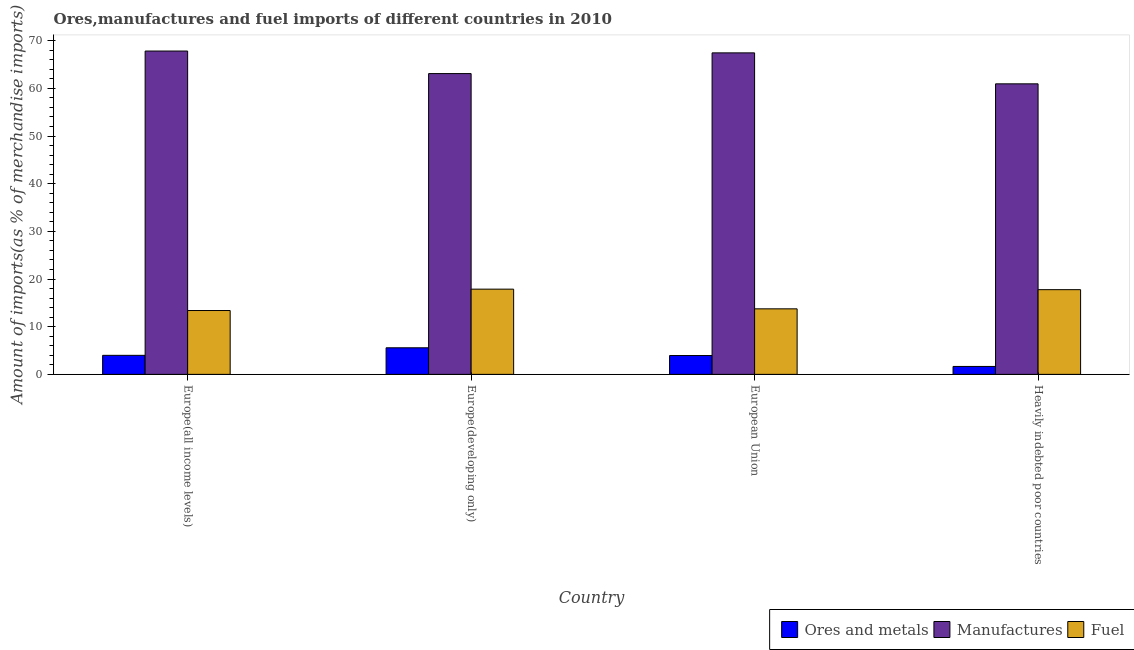How many groups of bars are there?
Your response must be concise. 4. Are the number of bars per tick equal to the number of legend labels?
Ensure brevity in your answer.  Yes. Are the number of bars on each tick of the X-axis equal?
Ensure brevity in your answer.  Yes. What is the label of the 3rd group of bars from the left?
Ensure brevity in your answer.  European Union. What is the percentage of ores and metals imports in Heavily indebted poor countries?
Provide a succinct answer. 1.66. Across all countries, what is the maximum percentage of fuel imports?
Your answer should be very brief. 17.88. Across all countries, what is the minimum percentage of manufactures imports?
Your answer should be very brief. 60.94. In which country was the percentage of manufactures imports maximum?
Give a very brief answer. Europe(all income levels). In which country was the percentage of fuel imports minimum?
Your answer should be very brief. Europe(all income levels). What is the total percentage of manufactures imports in the graph?
Provide a succinct answer. 259.3. What is the difference between the percentage of ores and metals imports in Europe(all income levels) and that in Heavily indebted poor countries?
Offer a very short reply. 2.33. What is the difference between the percentage of manufactures imports in Europe(all income levels) and the percentage of fuel imports in Europe(developing only)?
Provide a succinct answer. 49.95. What is the average percentage of fuel imports per country?
Offer a terse response. 15.7. What is the difference between the percentage of fuel imports and percentage of manufactures imports in Heavily indebted poor countries?
Give a very brief answer. -43.17. What is the ratio of the percentage of ores and metals imports in Europe(developing only) to that in Heavily indebted poor countries?
Your response must be concise. 3.36. Is the percentage of fuel imports in Europe(developing only) less than that in European Union?
Provide a short and direct response. No. What is the difference between the highest and the second highest percentage of ores and metals imports?
Your answer should be compact. 1.58. What is the difference between the highest and the lowest percentage of ores and metals imports?
Your answer should be compact. 3.91. What does the 2nd bar from the left in Europe(developing only) represents?
Make the answer very short. Manufactures. What does the 3rd bar from the right in Heavily indebted poor countries represents?
Offer a terse response. Ores and metals. How many bars are there?
Make the answer very short. 12. What is the difference between two consecutive major ticks on the Y-axis?
Provide a succinct answer. 10. How many legend labels are there?
Your response must be concise. 3. What is the title of the graph?
Your answer should be very brief. Ores,manufactures and fuel imports of different countries in 2010. What is the label or title of the X-axis?
Your answer should be compact. Country. What is the label or title of the Y-axis?
Your answer should be very brief. Amount of imports(as % of merchandise imports). What is the Amount of imports(as % of merchandise imports) in Ores and metals in Europe(all income levels)?
Provide a succinct answer. 3.99. What is the Amount of imports(as % of merchandise imports) of Manufactures in Europe(all income levels)?
Provide a succinct answer. 67.82. What is the Amount of imports(as % of merchandise imports) of Fuel in Europe(all income levels)?
Your answer should be very brief. 13.39. What is the Amount of imports(as % of merchandise imports) of Ores and metals in Europe(developing only)?
Offer a terse response. 5.58. What is the Amount of imports(as % of merchandise imports) of Manufactures in Europe(developing only)?
Your answer should be compact. 63.09. What is the Amount of imports(as % of merchandise imports) of Fuel in Europe(developing only)?
Offer a terse response. 17.88. What is the Amount of imports(as % of merchandise imports) in Ores and metals in European Union?
Provide a short and direct response. 3.95. What is the Amount of imports(as % of merchandise imports) in Manufactures in European Union?
Make the answer very short. 67.44. What is the Amount of imports(as % of merchandise imports) of Fuel in European Union?
Your answer should be compact. 13.75. What is the Amount of imports(as % of merchandise imports) in Ores and metals in Heavily indebted poor countries?
Keep it short and to the point. 1.66. What is the Amount of imports(as % of merchandise imports) in Manufactures in Heavily indebted poor countries?
Your answer should be compact. 60.94. What is the Amount of imports(as % of merchandise imports) of Fuel in Heavily indebted poor countries?
Keep it short and to the point. 17.77. Across all countries, what is the maximum Amount of imports(as % of merchandise imports) of Ores and metals?
Provide a short and direct response. 5.58. Across all countries, what is the maximum Amount of imports(as % of merchandise imports) of Manufactures?
Keep it short and to the point. 67.82. Across all countries, what is the maximum Amount of imports(as % of merchandise imports) in Fuel?
Offer a terse response. 17.88. Across all countries, what is the minimum Amount of imports(as % of merchandise imports) in Ores and metals?
Offer a terse response. 1.66. Across all countries, what is the minimum Amount of imports(as % of merchandise imports) in Manufactures?
Your response must be concise. 60.94. Across all countries, what is the minimum Amount of imports(as % of merchandise imports) of Fuel?
Your response must be concise. 13.39. What is the total Amount of imports(as % of merchandise imports) in Ores and metals in the graph?
Ensure brevity in your answer.  15.18. What is the total Amount of imports(as % of merchandise imports) of Manufactures in the graph?
Keep it short and to the point. 259.3. What is the total Amount of imports(as % of merchandise imports) in Fuel in the graph?
Ensure brevity in your answer.  62.78. What is the difference between the Amount of imports(as % of merchandise imports) in Ores and metals in Europe(all income levels) and that in Europe(developing only)?
Keep it short and to the point. -1.58. What is the difference between the Amount of imports(as % of merchandise imports) of Manufactures in Europe(all income levels) and that in Europe(developing only)?
Your answer should be compact. 4.73. What is the difference between the Amount of imports(as % of merchandise imports) of Fuel in Europe(all income levels) and that in Europe(developing only)?
Your response must be concise. -4.48. What is the difference between the Amount of imports(as % of merchandise imports) in Ores and metals in Europe(all income levels) and that in European Union?
Provide a short and direct response. 0.04. What is the difference between the Amount of imports(as % of merchandise imports) in Manufactures in Europe(all income levels) and that in European Union?
Make the answer very short. 0.38. What is the difference between the Amount of imports(as % of merchandise imports) of Fuel in Europe(all income levels) and that in European Union?
Your answer should be compact. -0.36. What is the difference between the Amount of imports(as % of merchandise imports) in Ores and metals in Europe(all income levels) and that in Heavily indebted poor countries?
Make the answer very short. 2.33. What is the difference between the Amount of imports(as % of merchandise imports) of Manufactures in Europe(all income levels) and that in Heavily indebted poor countries?
Make the answer very short. 6.88. What is the difference between the Amount of imports(as % of merchandise imports) in Fuel in Europe(all income levels) and that in Heavily indebted poor countries?
Provide a succinct answer. -4.38. What is the difference between the Amount of imports(as % of merchandise imports) in Ores and metals in Europe(developing only) and that in European Union?
Provide a short and direct response. 1.62. What is the difference between the Amount of imports(as % of merchandise imports) of Manufactures in Europe(developing only) and that in European Union?
Give a very brief answer. -4.34. What is the difference between the Amount of imports(as % of merchandise imports) in Fuel in Europe(developing only) and that in European Union?
Offer a terse response. 4.13. What is the difference between the Amount of imports(as % of merchandise imports) in Ores and metals in Europe(developing only) and that in Heavily indebted poor countries?
Give a very brief answer. 3.91. What is the difference between the Amount of imports(as % of merchandise imports) of Manufactures in Europe(developing only) and that in Heavily indebted poor countries?
Give a very brief answer. 2.15. What is the difference between the Amount of imports(as % of merchandise imports) in Fuel in Europe(developing only) and that in Heavily indebted poor countries?
Your answer should be compact. 0.11. What is the difference between the Amount of imports(as % of merchandise imports) of Ores and metals in European Union and that in Heavily indebted poor countries?
Make the answer very short. 2.29. What is the difference between the Amount of imports(as % of merchandise imports) in Manufactures in European Union and that in Heavily indebted poor countries?
Your response must be concise. 6.5. What is the difference between the Amount of imports(as % of merchandise imports) of Fuel in European Union and that in Heavily indebted poor countries?
Your response must be concise. -4.02. What is the difference between the Amount of imports(as % of merchandise imports) in Ores and metals in Europe(all income levels) and the Amount of imports(as % of merchandise imports) in Manufactures in Europe(developing only)?
Make the answer very short. -59.1. What is the difference between the Amount of imports(as % of merchandise imports) of Ores and metals in Europe(all income levels) and the Amount of imports(as % of merchandise imports) of Fuel in Europe(developing only)?
Offer a terse response. -13.88. What is the difference between the Amount of imports(as % of merchandise imports) in Manufactures in Europe(all income levels) and the Amount of imports(as % of merchandise imports) in Fuel in Europe(developing only)?
Your response must be concise. 49.95. What is the difference between the Amount of imports(as % of merchandise imports) in Ores and metals in Europe(all income levels) and the Amount of imports(as % of merchandise imports) in Manufactures in European Union?
Give a very brief answer. -63.44. What is the difference between the Amount of imports(as % of merchandise imports) in Ores and metals in Europe(all income levels) and the Amount of imports(as % of merchandise imports) in Fuel in European Union?
Give a very brief answer. -9.75. What is the difference between the Amount of imports(as % of merchandise imports) of Manufactures in Europe(all income levels) and the Amount of imports(as % of merchandise imports) of Fuel in European Union?
Provide a short and direct response. 54.07. What is the difference between the Amount of imports(as % of merchandise imports) in Ores and metals in Europe(all income levels) and the Amount of imports(as % of merchandise imports) in Manufactures in Heavily indebted poor countries?
Give a very brief answer. -56.95. What is the difference between the Amount of imports(as % of merchandise imports) of Ores and metals in Europe(all income levels) and the Amount of imports(as % of merchandise imports) of Fuel in Heavily indebted poor countries?
Offer a very short reply. -13.77. What is the difference between the Amount of imports(as % of merchandise imports) of Manufactures in Europe(all income levels) and the Amount of imports(as % of merchandise imports) of Fuel in Heavily indebted poor countries?
Provide a short and direct response. 50.05. What is the difference between the Amount of imports(as % of merchandise imports) in Ores and metals in Europe(developing only) and the Amount of imports(as % of merchandise imports) in Manufactures in European Union?
Provide a short and direct response. -61.86. What is the difference between the Amount of imports(as % of merchandise imports) of Ores and metals in Europe(developing only) and the Amount of imports(as % of merchandise imports) of Fuel in European Union?
Offer a very short reply. -8.17. What is the difference between the Amount of imports(as % of merchandise imports) in Manufactures in Europe(developing only) and the Amount of imports(as % of merchandise imports) in Fuel in European Union?
Provide a short and direct response. 49.35. What is the difference between the Amount of imports(as % of merchandise imports) of Ores and metals in Europe(developing only) and the Amount of imports(as % of merchandise imports) of Manufactures in Heavily indebted poor countries?
Provide a short and direct response. -55.37. What is the difference between the Amount of imports(as % of merchandise imports) in Ores and metals in Europe(developing only) and the Amount of imports(as % of merchandise imports) in Fuel in Heavily indebted poor countries?
Provide a succinct answer. -12.19. What is the difference between the Amount of imports(as % of merchandise imports) of Manufactures in Europe(developing only) and the Amount of imports(as % of merchandise imports) of Fuel in Heavily indebted poor countries?
Make the answer very short. 45.33. What is the difference between the Amount of imports(as % of merchandise imports) in Ores and metals in European Union and the Amount of imports(as % of merchandise imports) in Manufactures in Heavily indebted poor countries?
Provide a succinct answer. -56.99. What is the difference between the Amount of imports(as % of merchandise imports) in Ores and metals in European Union and the Amount of imports(as % of merchandise imports) in Fuel in Heavily indebted poor countries?
Provide a succinct answer. -13.82. What is the difference between the Amount of imports(as % of merchandise imports) of Manufactures in European Union and the Amount of imports(as % of merchandise imports) of Fuel in Heavily indebted poor countries?
Your answer should be very brief. 49.67. What is the average Amount of imports(as % of merchandise imports) of Ores and metals per country?
Make the answer very short. 3.8. What is the average Amount of imports(as % of merchandise imports) in Manufactures per country?
Provide a short and direct response. 64.82. What is the average Amount of imports(as % of merchandise imports) in Fuel per country?
Your response must be concise. 15.7. What is the difference between the Amount of imports(as % of merchandise imports) of Ores and metals and Amount of imports(as % of merchandise imports) of Manufactures in Europe(all income levels)?
Your answer should be very brief. -63.83. What is the difference between the Amount of imports(as % of merchandise imports) of Ores and metals and Amount of imports(as % of merchandise imports) of Fuel in Europe(all income levels)?
Your response must be concise. -9.4. What is the difference between the Amount of imports(as % of merchandise imports) of Manufactures and Amount of imports(as % of merchandise imports) of Fuel in Europe(all income levels)?
Ensure brevity in your answer.  54.43. What is the difference between the Amount of imports(as % of merchandise imports) of Ores and metals and Amount of imports(as % of merchandise imports) of Manufactures in Europe(developing only)?
Your answer should be very brief. -57.52. What is the difference between the Amount of imports(as % of merchandise imports) of Ores and metals and Amount of imports(as % of merchandise imports) of Fuel in Europe(developing only)?
Ensure brevity in your answer.  -12.3. What is the difference between the Amount of imports(as % of merchandise imports) in Manufactures and Amount of imports(as % of merchandise imports) in Fuel in Europe(developing only)?
Offer a terse response. 45.22. What is the difference between the Amount of imports(as % of merchandise imports) in Ores and metals and Amount of imports(as % of merchandise imports) in Manufactures in European Union?
Your response must be concise. -63.49. What is the difference between the Amount of imports(as % of merchandise imports) in Ores and metals and Amount of imports(as % of merchandise imports) in Fuel in European Union?
Provide a succinct answer. -9.8. What is the difference between the Amount of imports(as % of merchandise imports) of Manufactures and Amount of imports(as % of merchandise imports) of Fuel in European Union?
Your answer should be very brief. 53.69. What is the difference between the Amount of imports(as % of merchandise imports) of Ores and metals and Amount of imports(as % of merchandise imports) of Manufactures in Heavily indebted poor countries?
Keep it short and to the point. -59.28. What is the difference between the Amount of imports(as % of merchandise imports) of Ores and metals and Amount of imports(as % of merchandise imports) of Fuel in Heavily indebted poor countries?
Ensure brevity in your answer.  -16.11. What is the difference between the Amount of imports(as % of merchandise imports) of Manufactures and Amount of imports(as % of merchandise imports) of Fuel in Heavily indebted poor countries?
Your answer should be very brief. 43.17. What is the ratio of the Amount of imports(as % of merchandise imports) in Ores and metals in Europe(all income levels) to that in Europe(developing only)?
Offer a very short reply. 0.72. What is the ratio of the Amount of imports(as % of merchandise imports) in Manufactures in Europe(all income levels) to that in Europe(developing only)?
Your answer should be very brief. 1.07. What is the ratio of the Amount of imports(as % of merchandise imports) in Fuel in Europe(all income levels) to that in Europe(developing only)?
Provide a short and direct response. 0.75. What is the ratio of the Amount of imports(as % of merchandise imports) of Ores and metals in Europe(all income levels) to that in European Union?
Make the answer very short. 1.01. What is the ratio of the Amount of imports(as % of merchandise imports) in Manufactures in Europe(all income levels) to that in European Union?
Ensure brevity in your answer.  1.01. What is the ratio of the Amount of imports(as % of merchandise imports) in Fuel in Europe(all income levels) to that in European Union?
Provide a short and direct response. 0.97. What is the ratio of the Amount of imports(as % of merchandise imports) in Ores and metals in Europe(all income levels) to that in Heavily indebted poor countries?
Keep it short and to the point. 2.4. What is the ratio of the Amount of imports(as % of merchandise imports) of Manufactures in Europe(all income levels) to that in Heavily indebted poor countries?
Your answer should be compact. 1.11. What is the ratio of the Amount of imports(as % of merchandise imports) of Fuel in Europe(all income levels) to that in Heavily indebted poor countries?
Your answer should be compact. 0.75. What is the ratio of the Amount of imports(as % of merchandise imports) of Ores and metals in Europe(developing only) to that in European Union?
Offer a terse response. 1.41. What is the ratio of the Amount of imports(as % of merchandise imports) of Manufactures in Europe(developing only) to that in European Union?
Give a very brief answer. 0.94. What is the ratio of the Amount of imports(as % of merchandise imports) of Fuel in Europe(developing only) to that in European Union?
Your answer should be compact. 1.3. What is the ratio of the Amount of imports(as % of merchandise imports) in Ores and metals in Europe(developing only) to that in Heavily indebted poor countries?
Offer a terse response. 3.36. What is the ratio of the Amount of imports(as % of merchandise imports) in Manufactures in Europe(developing only) to that in Heavily indebted poor countries?
Give a very brief answer. 1.04. What is the ratio of the Amount of imports(as % of merchandise imports) in Ores and metals in European Union to that in Heavily indebted poor countries?
Provide a succinct answer. 2.38. What is the ratio of the Amount of imports(as % of merchandise imports) in Manufactures in European Union to that in Heavily indebted poor countries?
Provide a succinct answer. 1.11. What is the ratio of the Amount of imports(as % of merchandise imports) of Fuel in European Union to that in Heavily indebted poor countries?
Offer a very short reply. 0.77. What is the difference between the highest and the second highest Amount of imports(as % of merchandise imports) in Ores and metals?
Give a very brief answer. 1.58. What is the difference between the highest and the second highest Amount of imports(as % of merchandise imports) of Manufactures?
Your response must be concise. 0.38. What is the difference between the highest and the second highest Amount of imports(as % of merchandise imports) of Fuel?
Keep it short and to the point. 0.11. What is the difference between the highest and the lowest Amount of imports(as % of merchandise imports) of Ores and metals?
Your answer should be very brief. 3.91. What is the difference between the highest and the lowest Amount of imports(as % of merchandise imports) in Manufactures?
Your answer should be very brief. 6.88. What is the difference between the highest and the lowest Amount of imports(as % of merchandise imports) in Fuel?
Keep it short and to the point. 4.48. 